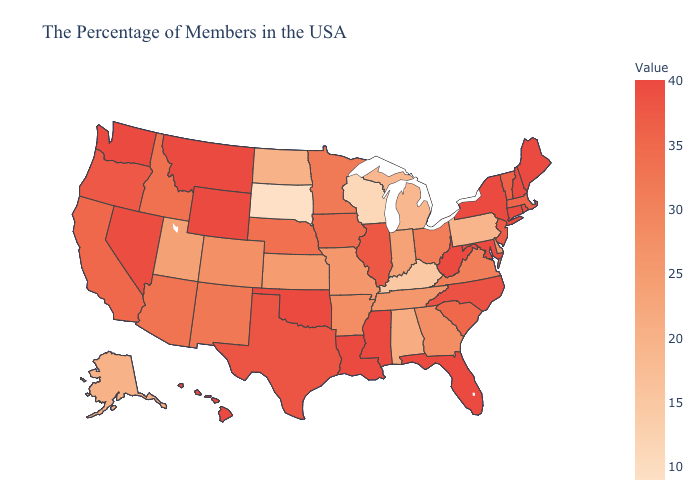Among the states that border New Mexico , does Texas have the lowest value?
Keep it brief. No. Among the states that border New Mexico , does Utah have the lowest value?
Keep it brief. Yes. 